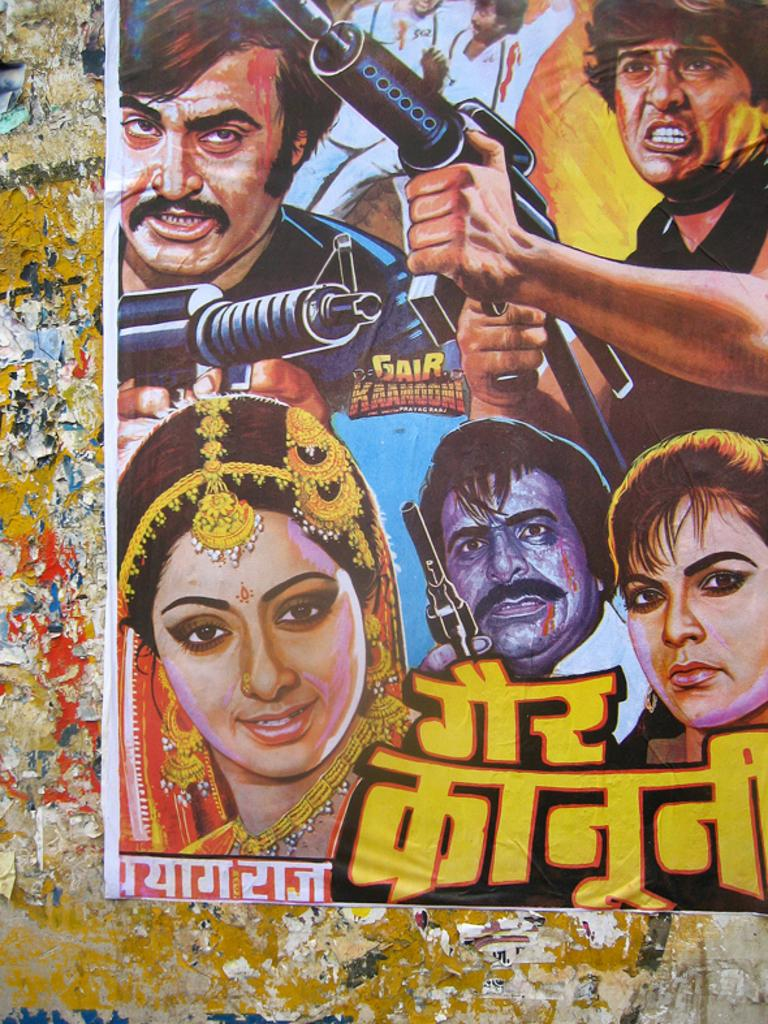What is featured on the poster in the image? There is a poster in the image that contains a group of people. What are some of the people in the poster doing? Some people in the poster are holding something. Is there any text on the poster? Yes, there is text written on the poster. Where is the poster located in the image? The poster is attached to a wall. What type of music can be heard coming from the person's knee in the image? There is no person or knee present in the image, and therefore no music can be heard. 